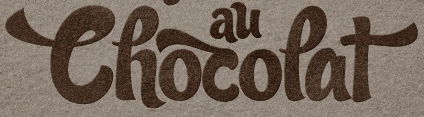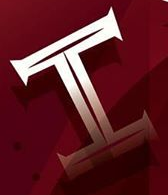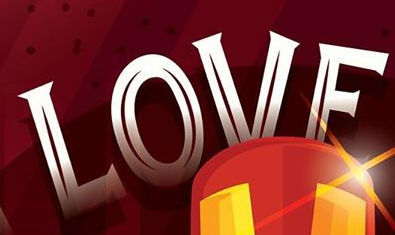What text is displayed in these images sequentially, separated by a semicolon? Thocopat; I; LOVE 